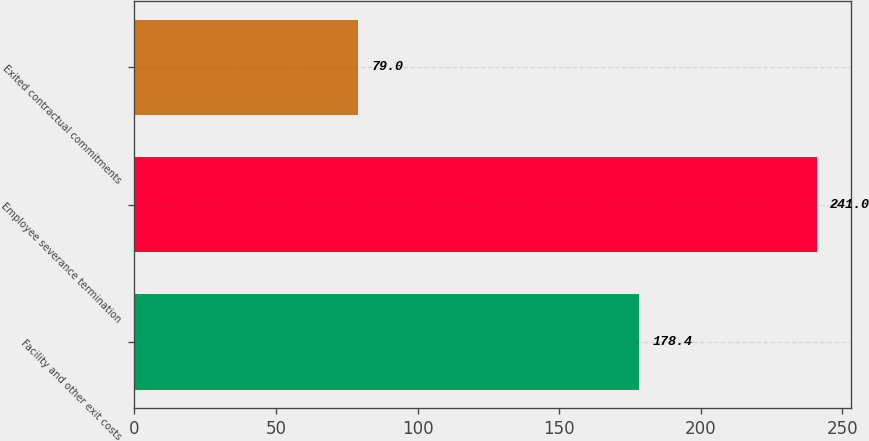Convert chart to OTSL. <chart><loc_0><loc_0><loc_500><loc_500><bar_chart><fcel>Facility and other exit costs<fcel>Employee severance termination<fcel>Exited contractual commitments<nl><fcel>178.4<fcel>241<fcel>79<nl></chart> 